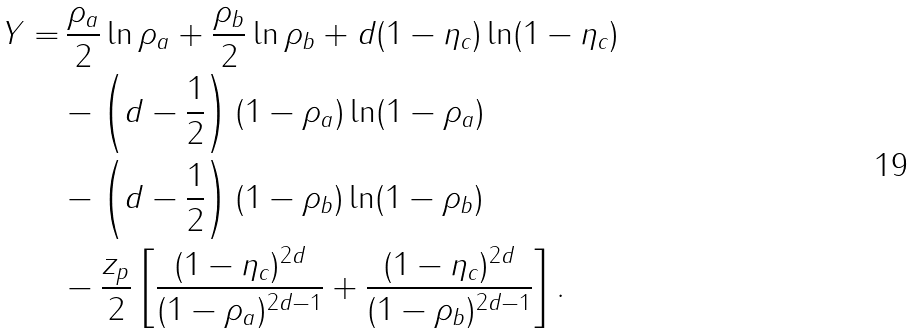Convert formula to latex. <formula><loc_0><loc_0><loc_500><loc_500>Y = & \, \frac { \rho _ { a } } { 2 } \ln \rho _ { a } + \frac { \rho _ { b } } { 2 } \ln \rho _ { b } + d ( 1 - \eta _ { c } ) \ln ( 1 - \eta _ { c } ) \\ & - \left ( d - { \frac { 1 } { 2 } } \right ) ( 1 - \rho _ { a } ) \ln ( 1 - \rho _ { a } ) \\ & - \left ( d - { \frac { 1 } { 2 } } \right ) ( 1 - \rho _ { b } ) \ln ( 1 - \rho _ { b } ) \\ & - \frac { z _ { p } } { 2 } \left [ \frac { ( 1 - \eta _ { c } ) ^ { 2 d } } { ( 1 - \rho _ { a } ) ^ { 2 d - 1 } } + \frac { ( 1 - \eta _ { c } ) ^ { 2 d } } { ( 1 - \rho _ { b } ) ^ { 2 d - 1 } } \right ] .</formula> 